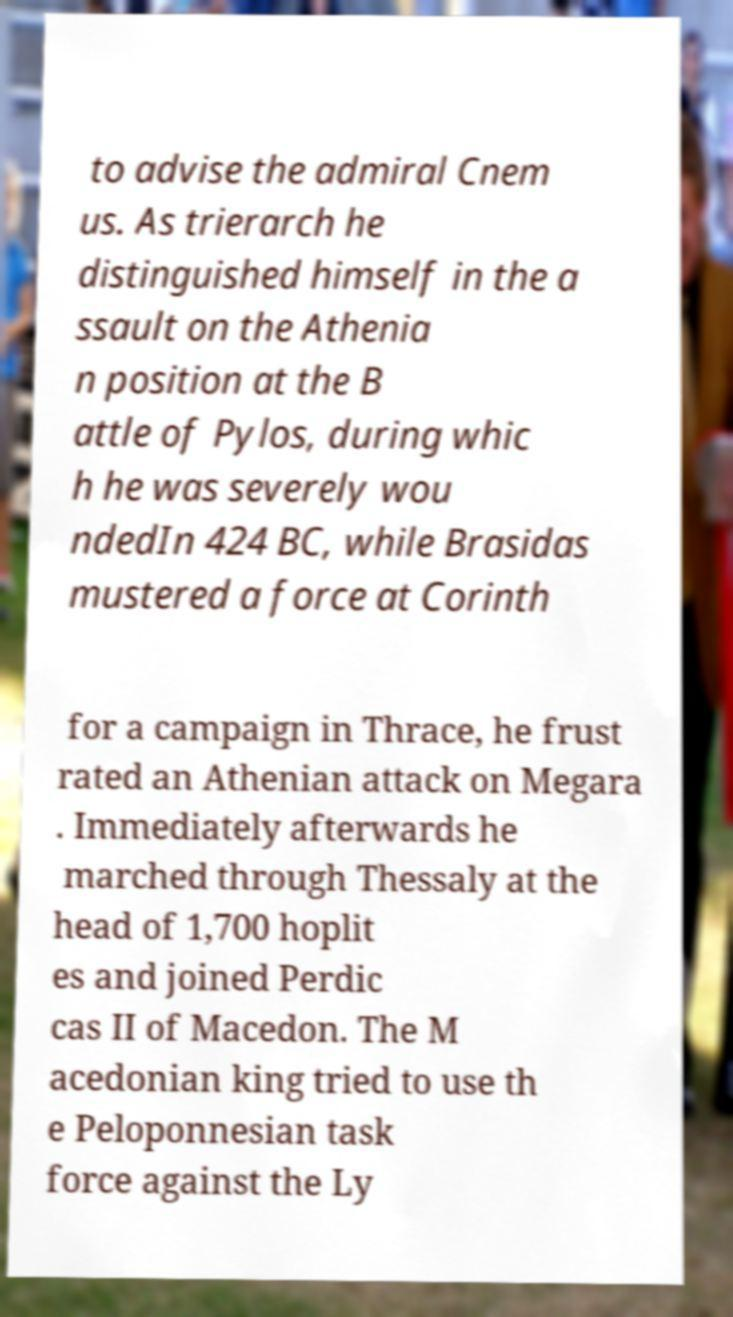I need the written content from this picture converted into text. Can you do that? to advise the admiral Cnem us. As trierarch he distinguished himself in the a ssault on the Athenia n position at the B attle of Pylos, during whic h he was severely wou ndedIn 424 BC, while Brasidas mustered a force at Corinth for a campaign in Thrace, he frust rated an Athenian attack on Megara . Immediately afterwards he marched through Thessaly at the head of 1,700 hoplit es and joined Perdic cas II of Macedon. The M acedonian king tried to use th e Peloponnesian task force against the Ly 